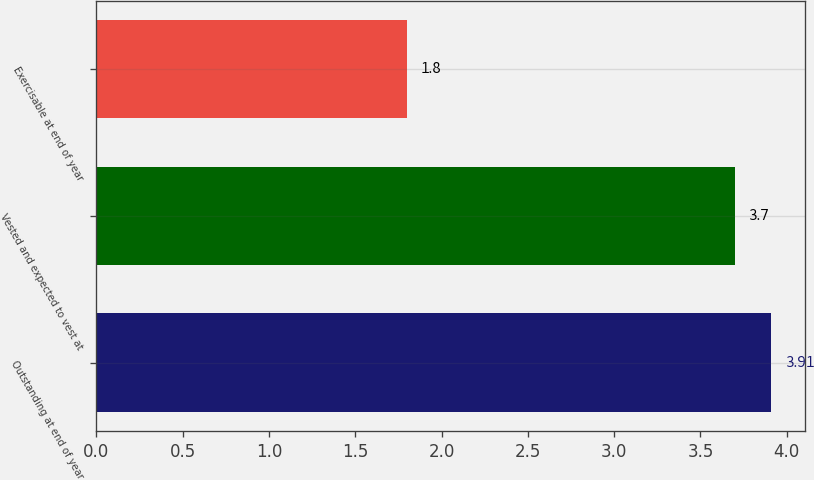Convert chart to OTSL. <chart><loc_0><loc_0><loc_500><loc_500><bar_chart><fcel>Outstanding at end of year<fcel>Vested and expected to vest at<fcel>Exercisable at end of year<nl><fcel>3.91<fcel>3.7<fcel>1.8<nl></chart> 